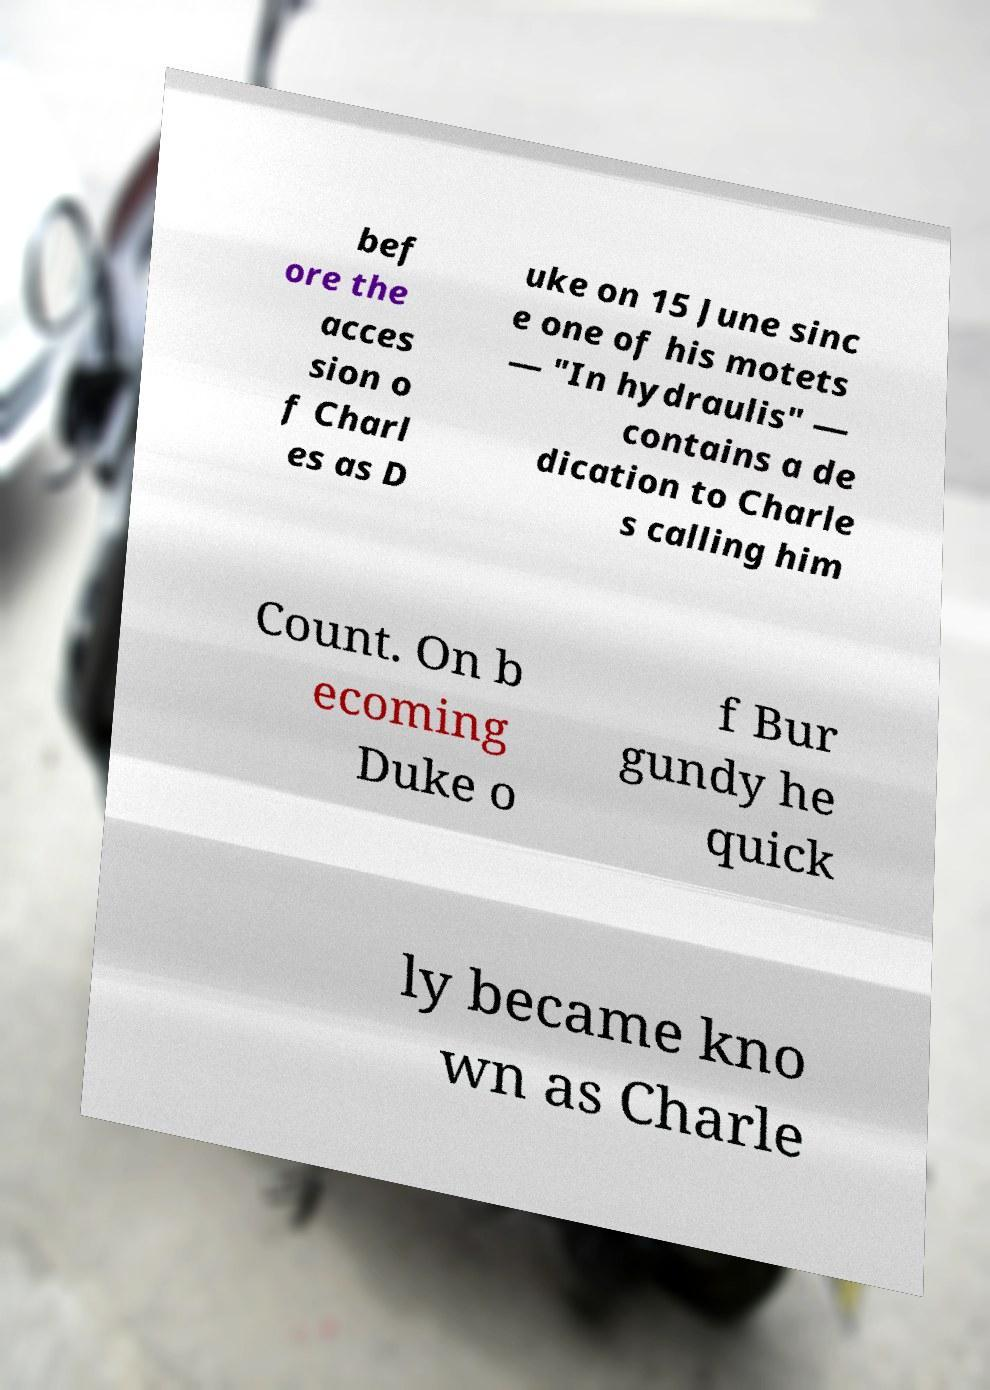Could you assist in decoding the text presented in this image and type it out clearly? bef ore the acces sion o f Charl es as D uke on 15 June sinc e one of his motets — "In hydraulis" — contains a de dication to Charle s calling him Count. On b ecoming Duke o f Bur gundy he quick ly became kno wn as Charle 